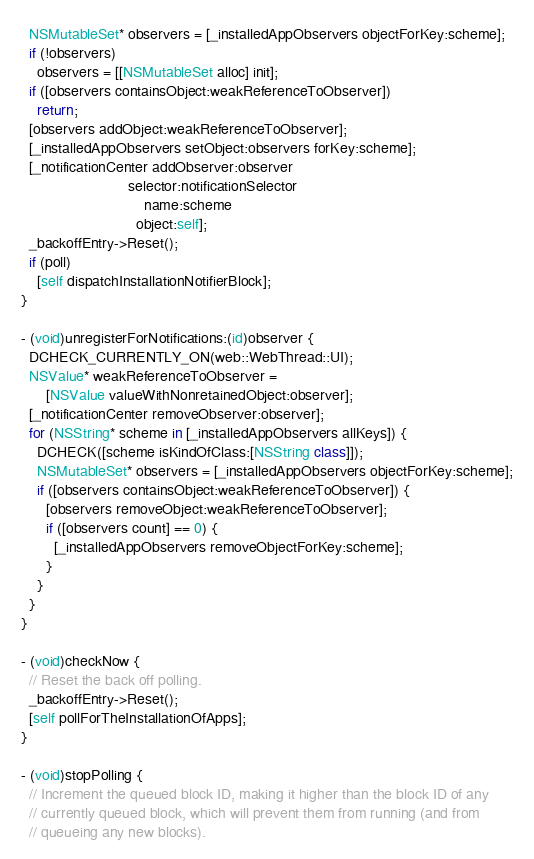<code> <loc_0><loc_0><loc_500><loc_500><_ObjectiveC_>  NSMutableSet* observers = [_installedAppObservers objectForKey:scheme];
  if (!observers)
    observers = [[NSMutableSet alloc] init];
  if ([observers containsObject:weakReferenceToObserver])
    return;
  [observers addObject:weakReferenceToObserver];
  [_installedAppObservers setObject:observers forKey:scheme];
  [_notificationCenter addObserver:observer
                          selector:notificationSelector
                              name:scheme
                            object:self];
  _backoffEntry->Reset();
  if (poll)
    [self dispatchInstallationNotifierBlock];
}

- (void)unregisterForNotifications:(id)observer {
  DCHECK_CURRENTLY_ON(web::WebThread::UI);
  NSValue* weakReferenceToObserver =
      [NSValue valueWithNonretainedObject:observer];
  [_notificationCenter removeObserver:observer];
  for (NSString* scheme in [_installedAppObservers allKeys]) {
    DCHECK([scheme isKindOfClass:[NSString class]]);
    NSMutableSet* observers = [_installedAppObservers objectForKey:scheme];
    if ([observers containsObject:weakReferenceToObserver]) {
      [observers removeObject:weakReferenceToObserver];
      if ([observers count] == 0) {
        [_installedAppObservers removeObjectForKey:scheme];
      }
    }
  }
}

- (void)checkNow {
  // Reset the back off polling.
  _backoffEntry->Reset();
  [self pollForTheInstallationOfApps];
}

- (void)stopPolling {
  // Increment the queued block ID, making it higher than the block ID of any
  // currently queued block, which will prevent them from running (and from
  // queueing any new blocks).</code> 